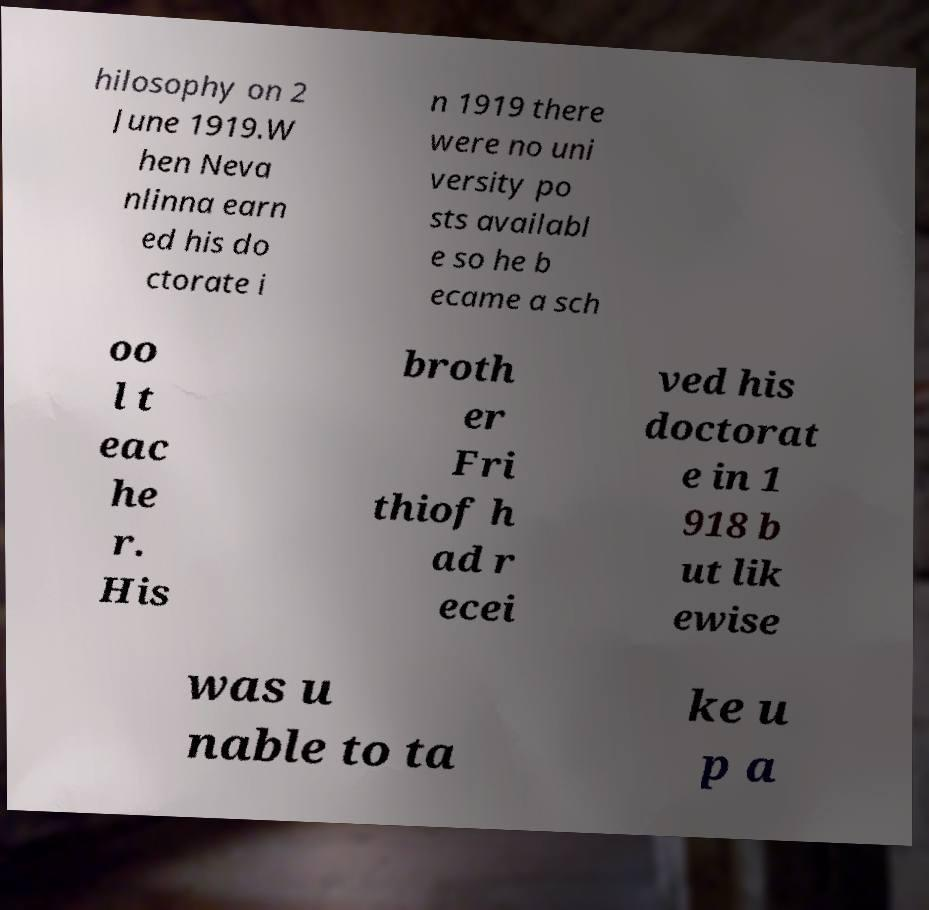Please identify and transcribe the text found in this image. hilosophy on 2 June 1919.W hen Neva nlinna earn ed his do ctorate i n 1919 there were no uni versity po sts availabl e so he b ecame a sch oo l t eac he r. His broth er Fri thiof h ad r ecei ved his doctorat e in 1 918 b ut lik ewise was u nable to ta ke u p a 